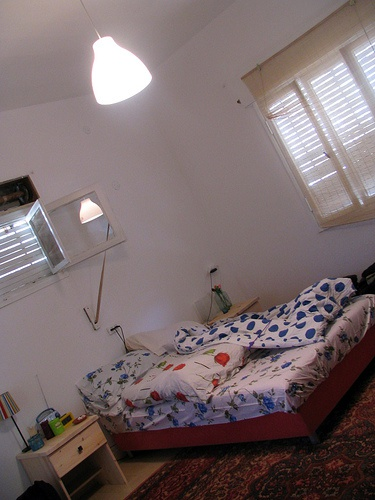Describe the objects in this image and their specific colors. I can see bed in darkgray, gray, and black tones and vase in darkgray, black, and gray tones in this image. 